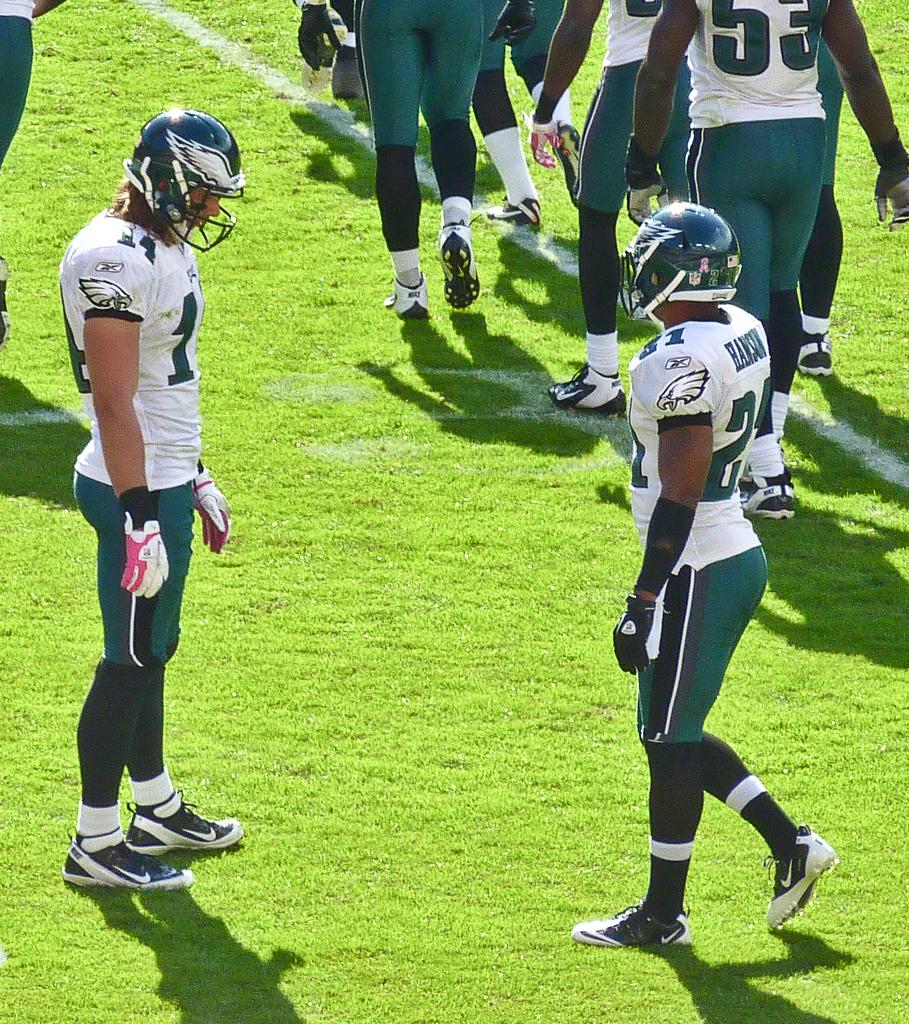What are the two persons in the image wearing on their heads? The two persons in the image are wearing helmets. Can you describe the setting where the two persons are located? The two persons are standing on the grass in the image. What is happening in the background of the image? There is a group of people standing on the grass in the background of the image. What type of zinc is being used to construct the bridge in the image? There is no bridge present in the image, so it is not possible to determine what type of zinc might be used in its construction. 